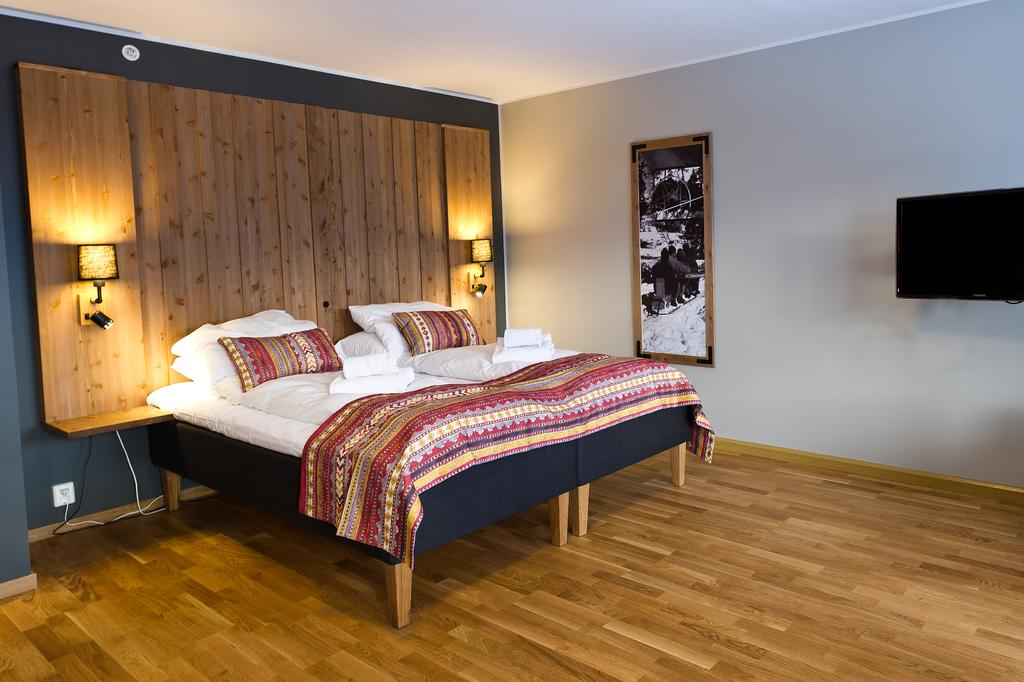What type of furniture is present in the image? There is a bed in the image. What is on the bed? The bed contains pillows and is covered with a bed sheet. What electronic device is visible in the image? There is a TV in the image. What type of decoration is on the wall in the image? There is a painting on the wall in the image. What type of boot is hanging on the painting in the image? There is no boot present in the image; the painting is the only decorative element mentioned. 